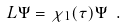Convert formula to latex. <formula><loc_0><loc_0><loc_500><loc_500>L \Psi = \chi _ { 1 } ( \tau ) \Psi \ .</formula> 